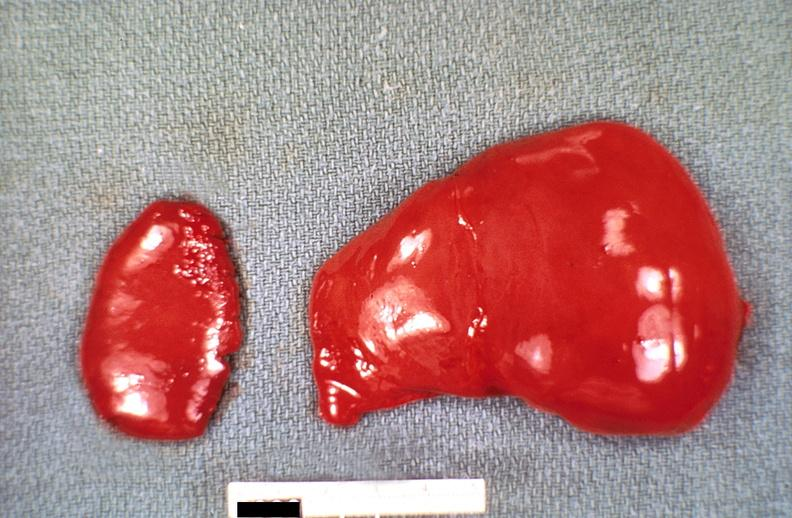does this image show liver and spleen, congestion, hemolytic disease of newborn?
Answer the question using a single word or phrase. Yes 